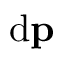<formula> <loc_0><loc_0><loc_500><loc_500>d p</formula> 